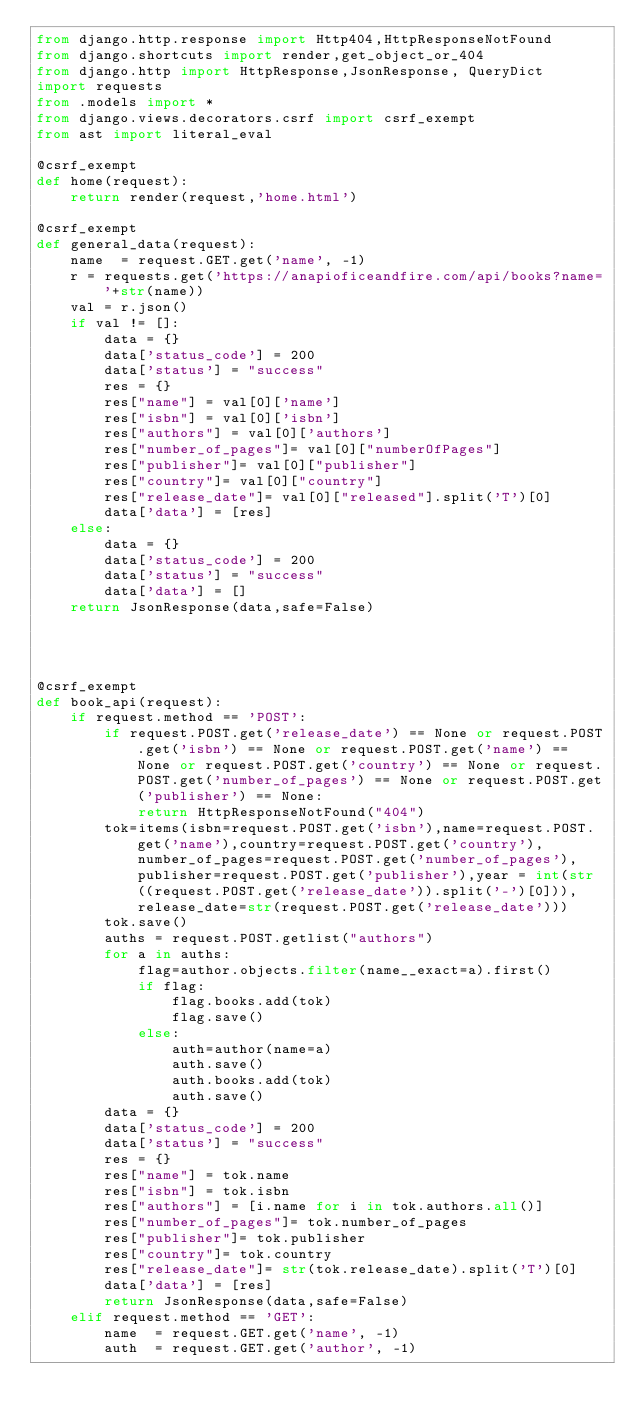Convert code to text. <code><loc_0><loc_0><loc_500><loc_500><_Python_>from django.http.response import Http404,HttpResponseNotFound
from django.shortcuts import render,get_object_or_404
from django.http import HttpResponse,JsonResponse, QueryDict
import requests
from .models import *
from django.views.decorators.csrf import csrf_exempt
from ast import literal_eval

@csrf_exempt 
def home(request):
    return render(request,'home.html')

@csrf_exempt 
def general_data(request):
    name  = request.GET.get('name', -1)
    r = requests.get('https://anapioficeandfire.com/api/books?name='+str(name))
    val = r.json()
    if val != []:
        data = {}
        data['status_code'] = 200
        data['status'] = "success"
        res = {}
        res["name"] = val[0]['name']
        res["isbn"] = val[0]['isbn']
        res["authors"] = val[0]['authors']
        res["number_of_pages"]= val[0]["numberOfPages"]
        res["publisher"]= val[0]["publisher"]
        res["country"]= val[0]["country"]
        res["release_date"]= val[0]["released"].split('T')[0]
        data['data'] = [res]
    else:
        data = {}
        data['status_code'] = 200
        data['status'] = "success"
        data['data'] = []
    return JsonResponse(data,safe=False)
        
    


@csrf_exempt 
def book_api(request):
    if request.method == 'POST':
        if request.POST.get('release_date') == None or request.POST.get('isbn') == None or request.POST.get('name') == None or request.POST.get('country') == None or request.POST.get('number_of_pages') == None or request.POST.get('publisher') == None:
            return HttpResponseNotFound("404")
        tok=items(isbn=request.POST.get('isbn'),name=request.POST.get('name'),country=request.POST.get('country'),number_of_pages=request.POST.get('number_of_pages'),publisher=request.POST.get('publisher'),year = int(str((request.POST.get('release_date')).split('-')[0])),release_date=str(request.POST.get('release_date')))
        tok.save()
        auths = request.POST.getlist("authors")
        for a in auths:
            flag=author.objects.filter(name__exact=a).first()
            if flag:
                flag.books.add(tok)
                flag.save()
            else:
                auth=author(name=a)
                auth.save()
                auth.books.add(tok)
                auth.save()
        data = {}
        data['status_code'] = 200
        data['status'] = "success"
        res = {}
        res["name"] = tok.name
        res["isbn"] = tok.isbn
        res["authors"] = [i.name for i in tok.authors.all()]
        res["number_of_pages"]= tok.number_of_pages
        res["publisher"]= tok.publisher
        res["country"]= tok.country
        res["release_date"]= str(tok.release_date).split('T')[0]
        data['data'] = [res]
        return JsonResponse(data,safe=False)
    elif request.method == 'GET':
        name  = request.GET.get('name', -1)
        auth  = request.GET.get('author', -1)</code> 